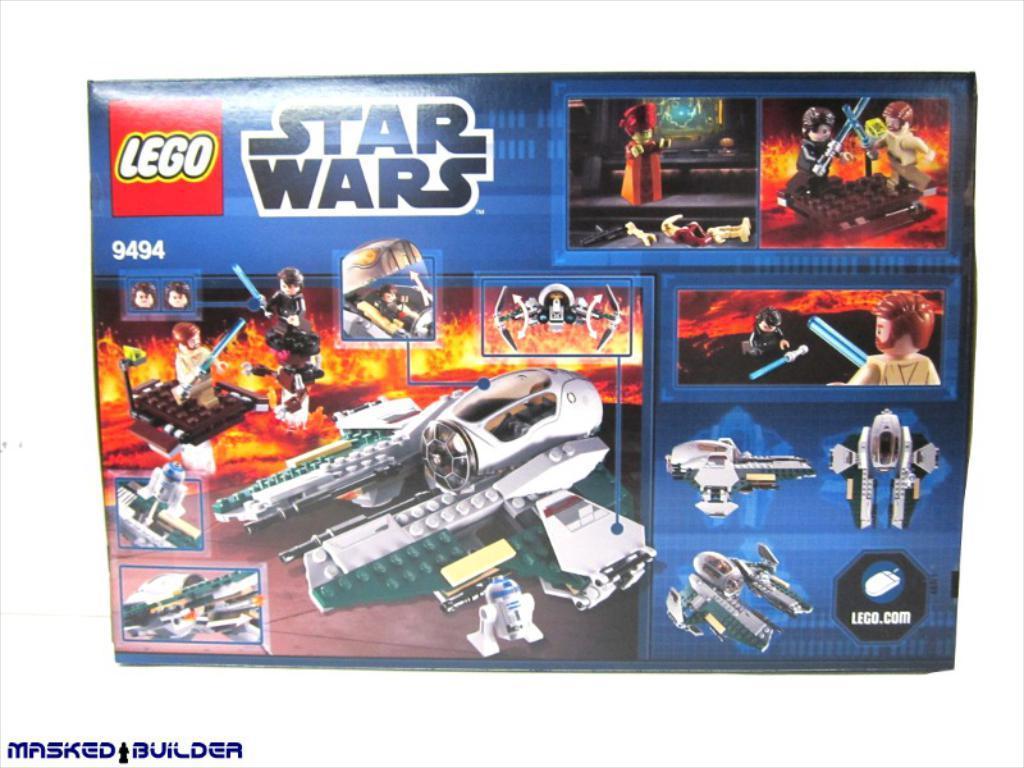How would you summarize this image in a sentence or two? In the picture I can see an object which has photos of toys and something written on the image. On the bottom left side of the image I can see something written on the image. The background of the image is white in color. 